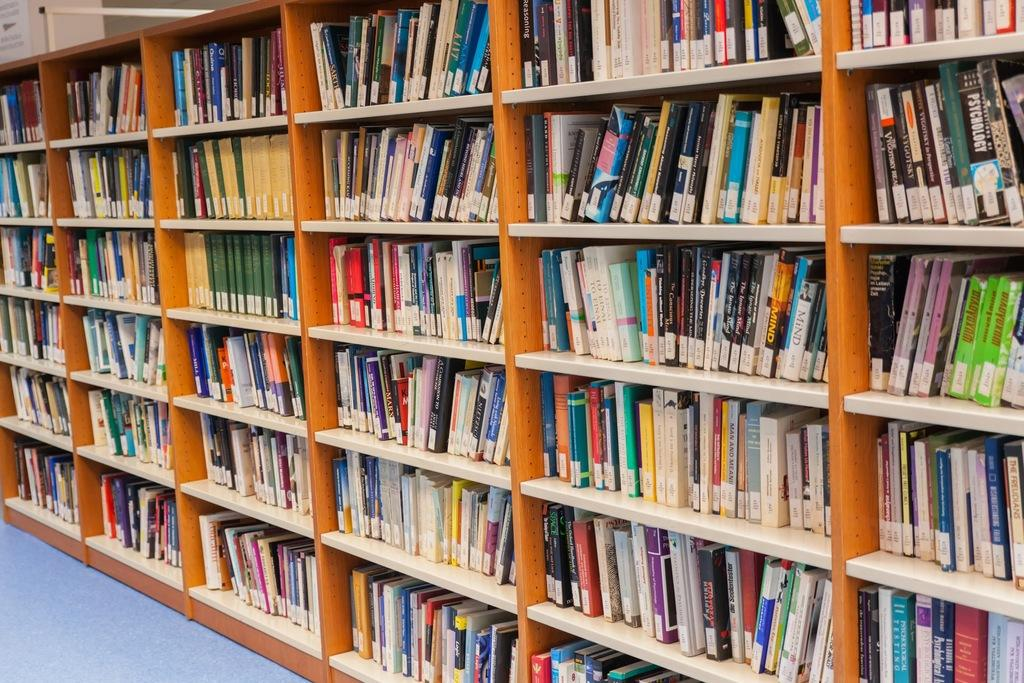What objects are on the rack in the image? There are books on a rack in the image. What part of the room can be seen at the bottom of the image? There is a floor visible at the bottom of the image. What type of flesh can be seen being digested in the image? There is no flesh or digestion present in the image; it features books on a rack and a floor. 